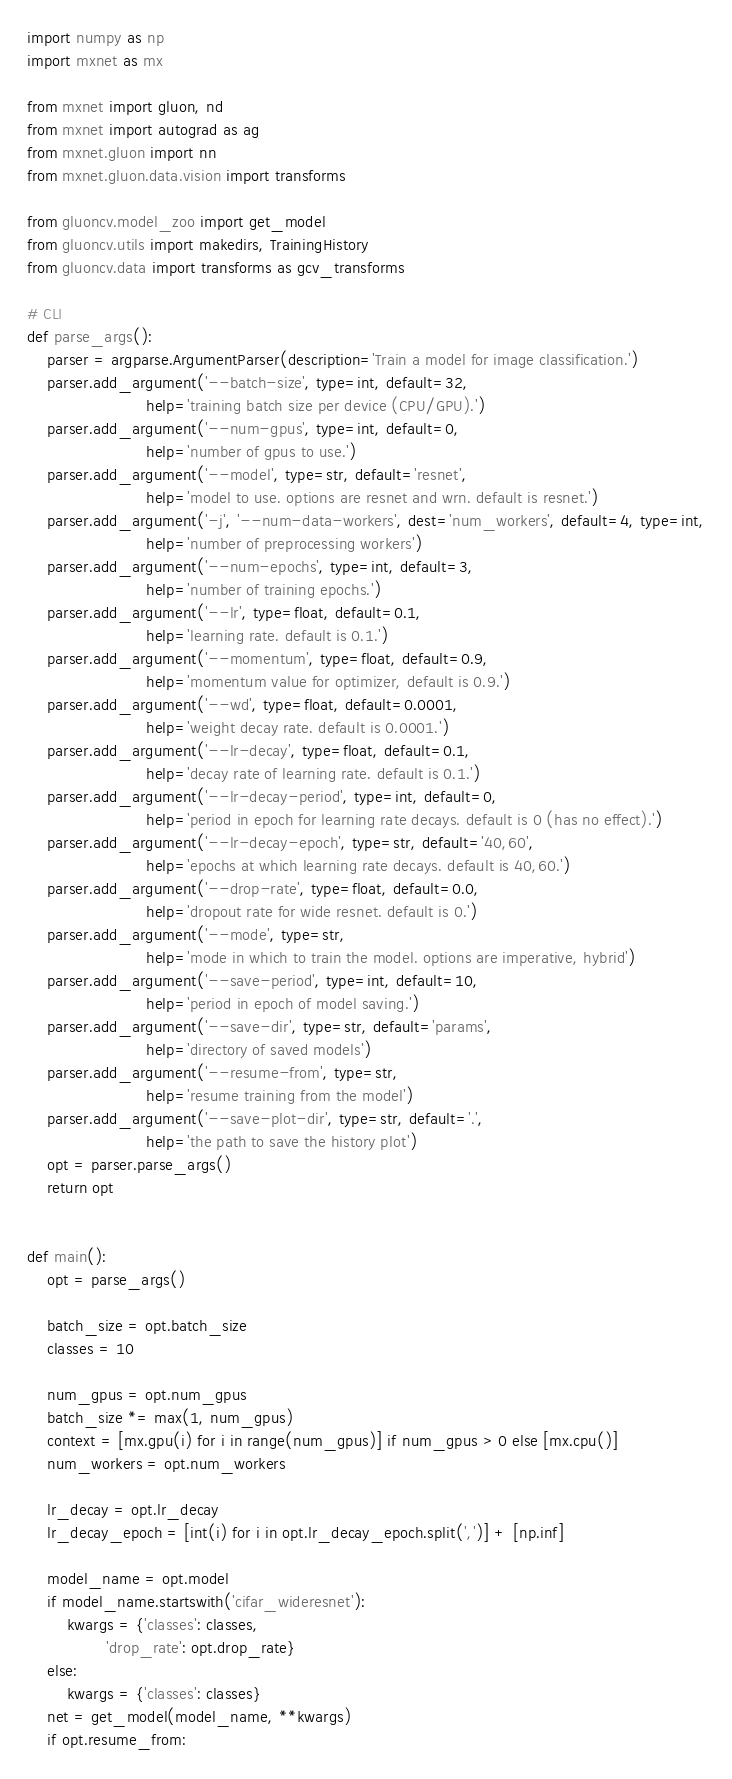<code> <loc_0><loc_0><loc_500><loc_500><_Python_>
import numpy as np
import mxnet as mx

from mxnet import gluon, nd
from mxnet import autograd as ag
from mxnet.gluon import nn
from mxnet.gluon.data.vision import transforms

from gluoncv.model_zoo import get_model
from gluoncv.utils import makedirs, TrainingHistory
from gluoncv.data import transforms as gcv_transforms

# CLI
def parse_args():
    parser = argparse.ArgumentParser(description='Train a model for image classification.')
    parser.add_argument('--batch-size', type=int, default=32,
                        help='training batch size per device (CPU/GPU).')
    parser.add_argument('--num-gpus', type=int, default=0,
                        help='number of gpus to use.')
    parser.add_argument('--model', type=str, default='resnet',
                        help='model to use. options are resnet and wrn. default is resnet.')
    parser.add_argument('-j', '--num-data-workers', dest='num_workers', default=4, type=int,
                        help='number of preprocessing workers')
    parser.add_argument('--num-epochs', type=int, default=3,
                        help='number of training epochs.')
    parser.add_argument('--lr', type=float, default=0.1,
                        help='learning rate. default is 0.1.')
    parser.add_argument('--momentum', type=float, default=0.9,
                        help='momentum value for optimizer, default is 0.9.')
    parser.add_argument('--wd', type=float, default=0.0001,
                        help='weight decay rate. default is 0.0001.')
    parser.add_argument('--lr-decay', type=float, default=0.1,
                        help='decay rate of learning rate. default is 0.1.')
    parser.add_argument('--lr-decay-period', type=int, default=0,
                        help='period in epoch for learning rate decays. default is 0 (has no effect).')
    parser.add_argument('--lr-decay-epoch', type=str, default='40,60',
                        help='epochs at which learning rate decays. default is 40,60.')
    parser.add_argument('--drop-rate', type=float, default=0.0,
                        help='dropout rate for wide resnet. default is 0.')
    parser.add_argument('--mode', type=str,
                        help='mode in which to train the model. options are imperative, hybrid')
    parser.add_argument('--save-period', type=int, default=10,
                        help='period in epoch of model saving.')
    parser.add_argument('--save-dir', type=str, default='params',
                        help='directory of saved models')
    parser.add_argument('--resume-from', type=str,
                        help='resume training from the model')
    parser.add_argument('--save-plot-dir', type=str, default='.',
                        help='the path to save the history plot')
    opt = parser.parse_args()
    return opt


def main():
    opt = parse_args()
    
    batch_size = opt.batch_size
    classes = 10

    num_gpus = opt.num_gpus
    batch_size *= max(1, num_gpus)
    context = [mx.gpu(i) for i in range(num_gpus)] if num_gpus > 0 else [mx.cpu()]
    num_workers = opt.num_workers

    lr_decay = opt.lr_decay
    lr_decay_epoch = [int(i) for i in opt.lr_decay_epoch.split(',')] + [np.inf]

    model_name = opt.model
    if model_name.startswith('cifar_wideresnet'):
        kwargs = {'classes': classes,
                'drop_rate': opt.drop_rate}
    else:
        kwargs = {'classes': classes}
    net = get_model(model_name, **kwargs)
    if opt.resume_from:</code> 